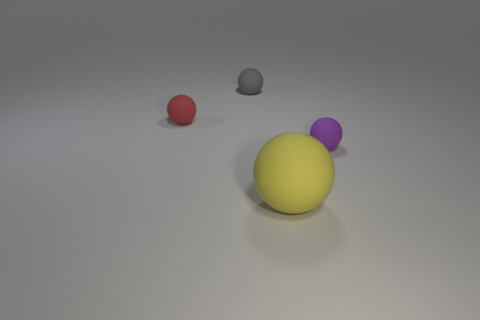Subtract 2 balls. How many balls are left? 2 Subtract all brown spheres. Subtract all brown cylinders. How many spheres are left? 4 Add 1 purple balls. How many objects exist? 5 Subtract all large red things. Subtract all small purple spheres. How many objects are left? 3 Add 2 red things. How many red things are left? 3 Add 2 tiny balls. How many tiny balls exist? 5 Subtract 0 purple cylinders. How many objects are left? 4 